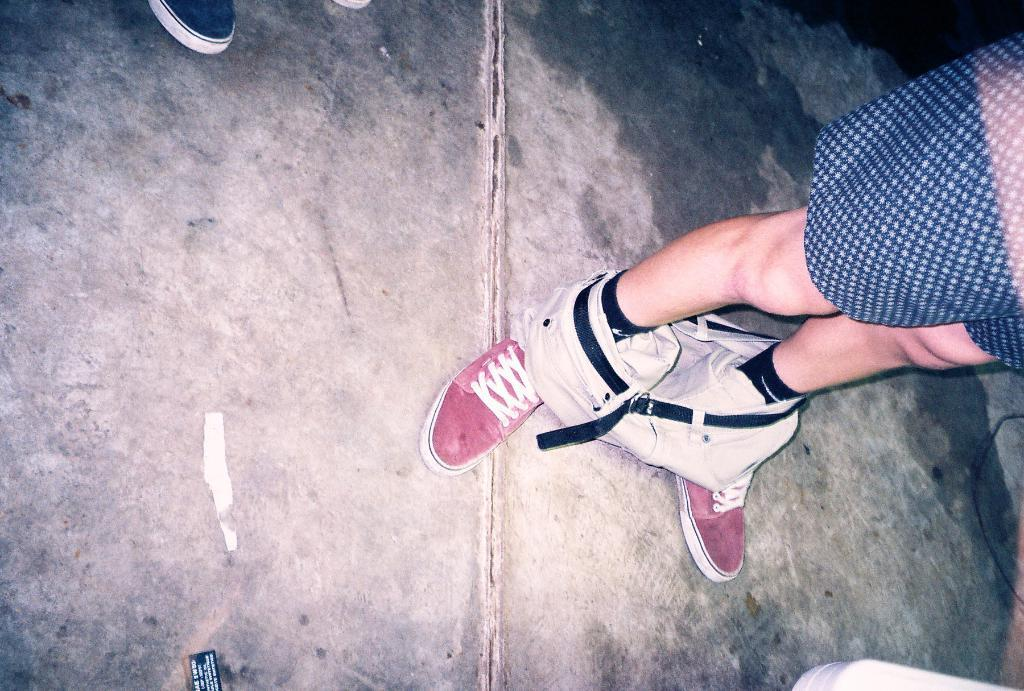What is the main subject of the image? There is a person standing on a path in the image. What can be observed about the person's attire? The person is wearing red shoes, and they have a belt. What is the condition of the person's pants? The person's pants are removed. What else can be seen near the person? A part of a shoe is visible beside the person. What type of operation is being performed on the person in the image? There is no operation being performed on the person in the image. How many quarters can be seen in the image? There are no quarters present in the image. 